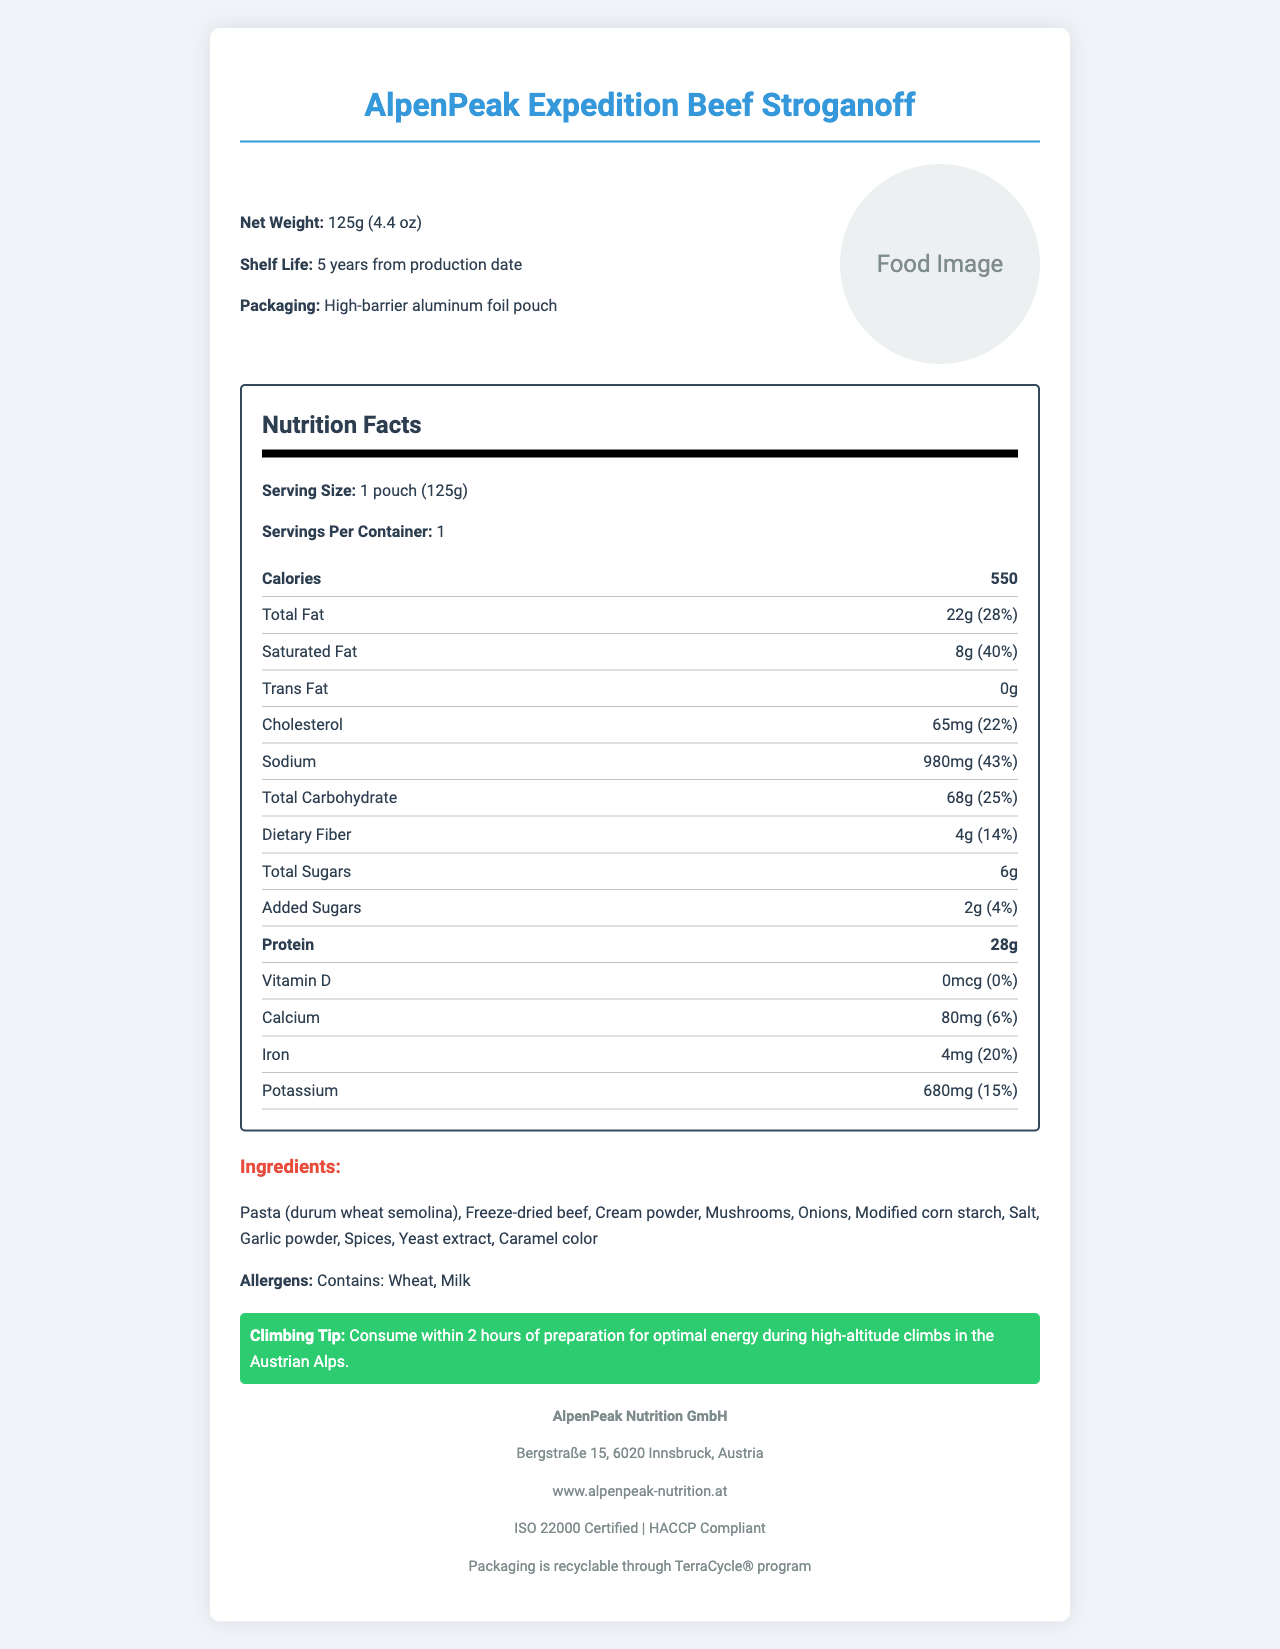what is the serving size? The serving size is specified as 1 pouch (125g) in the document.
Answer: 1 pouch (125g) how many calories are there in one serving? The document states that there are 550 calories per serving.
Answer: 550 what is the amount of protein per serving? The nutrition facts indicate that there are 28 grams of protein per serving.
Answer: 28g what are the main ingredients? The ingredients section lists these items as the main components of the meal.
Answer: Pasta (durum wheat semolina), Freeze-dried beef, Cream powder, Mushrooms, Onions, Modified corn starch, Salt, Garlic powder, Spices, Yeast extract, Caramel color how should you prepare the meal? The preparation instructions describe these steps in the document.
Answer: Add 350ml of boiling water directly to the pouch. Stir well and seal. Wait 8-10 minutes, stir again, and enjoy! how much sodium does one serving contain? The document specifies that there are 980mg of sodium per serving.
Answer: 980mg how long is the shelf life of the meal? The shelf life listed in the document is 5 years from the production date.
Answer: 5 years from production date what is the net weight of the product? According to the document, the net weight is 125g (4.4 oz).
Answer: 125g (4.4 oz) which certifications does the product have? The document lists these certifications.
Answer: ISO 22000 Certified, HACCP Compliant which of the following nutritional components has the highest daily value percentage? A. Saturated Fat B. Sodium C. Dietary Fiber The daily value for Saturated Fat is 40%, for Sodium is 43%, and for Dietary Fiber is 14%. Sodium has the highest daily value percentage.
Answer: B. Sodium how much added sugar is in one serving? A. 0g B. 2g C. 4g The document states that there are 2 grams of added sugars per serving.
Answer: B. 2g does the product contain any allergens? The allergens section indicates that the product contains wheat and milk.
Answer: Yes is the packaging of this product recyclable? The sustainability information specifies that the packaging is recyclable through the TerraCycle® program.
Answer: Yes describe the document. The document includes comprehensive details about the product, focusing on its nutritional content, ingredients, allergen information, preparation instructions, shelf life, and certifications. Additionally, it provides sustainability information and a special tip for climbers.
Answer: This document is the nutrition facts label for "AlpenPeak Expedition Beef Stroganoff." It includes details such as serving size, nutritional information, ingredients, allergens, preparation instructions, shelf life, packaging material, manufacturer info, certifications, sustainability info, and a climbing tip. how many carbohydrates are in one serving? The document provides the amount of total carbohydrates (68g) but does not specify how many of those are complex carbohydrates or simple carbohydrates. This makes it impossible to determine without additional information.
Answer: Cannot be determined what is the manufacturer's website? The document lists www.alpenpeak-nutrition.at as the manufacturer's website.
Answer: www.alpenpeak-nutrition.at 